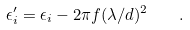<formula> <loc_0><loc_0><loc_500><loc_500>\epsilon _ { i } ^ { \prime } = \epsilon _ { i } - 2 \pi f ( \lambda / d ) ^ { 2 } \quad .</formula> 